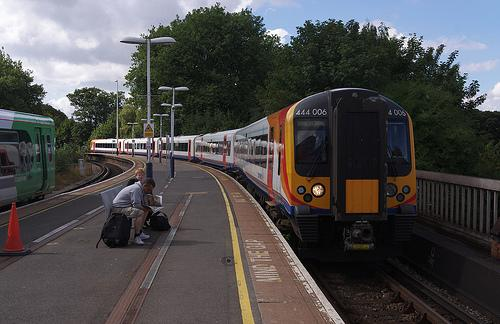Count the number of street lamps and light posts in the image. There are four street lamps and two light posts. How many people are present in the image, and what are they doing? There are two people, a man and a woman, sitting on a bench while waiting for the train at the station. Provide a concise summary of the image. A train is pulling into a station with commuters waiting on the platform; there are street lamps, an orange traffic cone, green trees, and stormy clouds in the background. List all the identifiable objects in the image. Train, train tracks, train platform, yellow safety line, orange traffic cone, street lamps, light post, sign on a light pole, trees, sky, clouds, headlight, door, windshield, train number, backpack, people sitting on a bench. Analyze the sentiment expressed in the image. The sentiment in the image is neutral, as it captures a common everyday event of people waiting for the train at the station. What specific details can be seen regarding the train? The train is green and white, has a front door, windshield, illuminated headlight, and a 6-digit identification number (444 006). For what kind of transportation has the train been employed? The train is being used for public transportation, specifically for commuting. Describe the setting of the scene in the image. The scene takes place at a train station platform with street lamps, a yellow safety line, green trees, and storm clouds in the background. What are the prominent colors in the image? Green, white, orange, gray, yellow, and black. Describe the weather in the image. The weather is cloudy, as seen by the presence of growing storm clouds in the distance. 